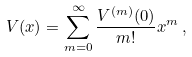Convert formula to latex. <formula><loc_0><loc_0><loc_500><loc_500>V ( x ) = \sum _ { m = 0 } ^ { \infty } \frac { V ^ { ( m ) } ( 0 ) } { m ! } x ^ { m } \, ,</formula> 